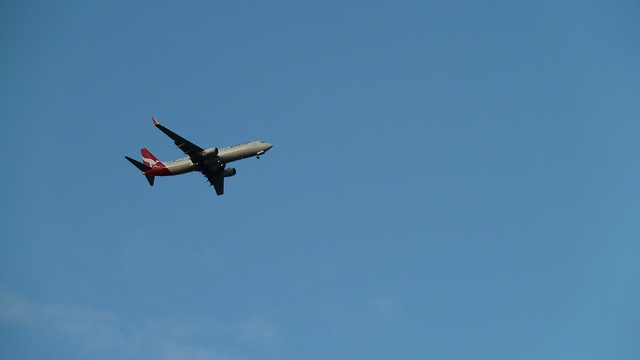Describe the objects in this image and their specific colors. I can see a airplane in blue, black, darkgray, gray, and maroon tones in this image. 